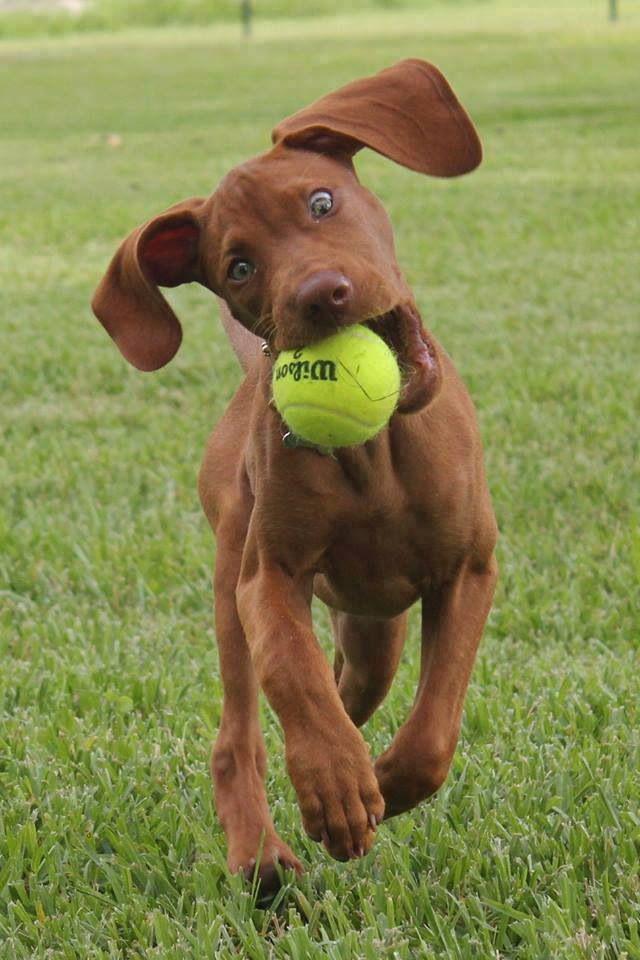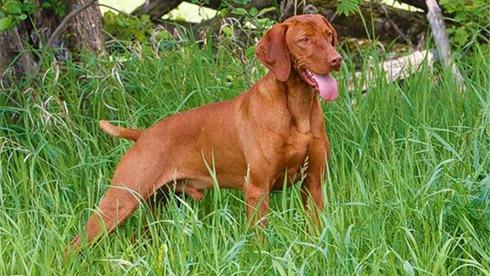The first image is the image on the left, the second image is the image on the right. Analyze the images presented: Is the assertion "A dog is holding something in its mouth." valid? Answer yes or no. Yes. The first image is the image on the left, the second image is the image on the right. For the images shown, is this caption "The dog on the left has something held in its mouth, and the dog on the right is standing on green grass with its tail extended." true? Answer yes or no. Yes. 